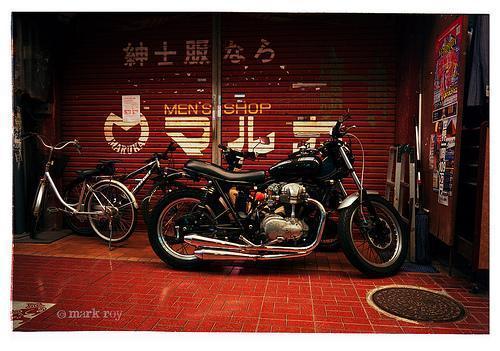How many motorcycles?
Give a very brief answer. 1. How many black motorcycles are there?
Give a very brief answer. 1. 